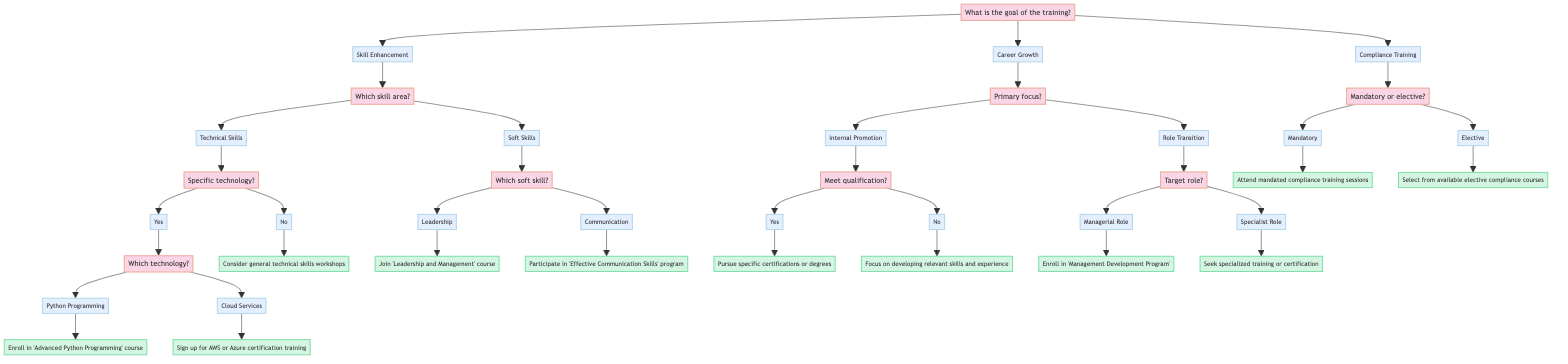What is the first question in the diagram? The diagram starts with the root question, which is "What is the goal of the training?" This is the opening node that guides the subsequent decision process.
Answer: What is the goal of the training? How many options are available under "Skill Enhancement"? Under "Skill Enhancement," there are two major options listed: "Technical Skills" and "Soft Skills." Therefore, the count of options is two.
Answer: 2 What action is suggested for someone wanting to improve "Leadership" skills? Following the path for "Soft Skills" and then selecting "Leadership," the suggested action is to "Join 'Leadership and Management' course at LinkedIn Learning."
Answer: Join 'Leadership and Management' course at LinkedIn Learning If a user selects "Compliance Training" and chooses "Mandatory," what is the outcome? The pathway indicates that choosing "Mandatory" directs the user to the action to "Attend the company’s mandated compliance training sessions." This is a direct consequence of that choice.
Answer: Attend the company’s mandated compliance training sessions What is the action for someone targeting a "Managerial Role"? Following the path from "Role Transition" and choosing "Managerial Role," the recommended action is to "Enroll in 'Management Development Program' offered by top universities." This involves a direct training program suited for that role.
Answer: Enroll in 'Management Development Program' What do you focus on if there is "No" qualification needed for "Internal Promotion"? If the answer to "Do you need to meet a certain qualification?" under "Internal Promotion" is "No," then the focus shifts to "Developing relevant skills and gaining experience through projects." Thus, the outcome is based on skill development.
Answer: Focus on developing relevant skills and gaining experience through projects Which course is offered for "Cloud Services" skill enhancement? Upon selecting "Technical Skills," choosing "Yes" for specific technology leads to the action to "Sign up for AWS or Azure certification training" specifically for improving competency in cloud services.
Answer: Sign up for AWS or Azure certification training What are the options after asking "Which skill area do you want to improve?" The options following this question are "Technical Skills" and "Soft Skills." There are only two branches that emerge from this point.
Answer: Technical Skills, Soft Skills What training programs are available for "Communication" skills? By selecting the "Soft Skills" category and then "Communication," the diagram suggests "Participate in 'Effective Communication Skills' program by Dale Carnegie" as the specific action for enhancing communication skills.
Answer: Participate in 'Effective Communication Skills' program by Dale Carnegie 